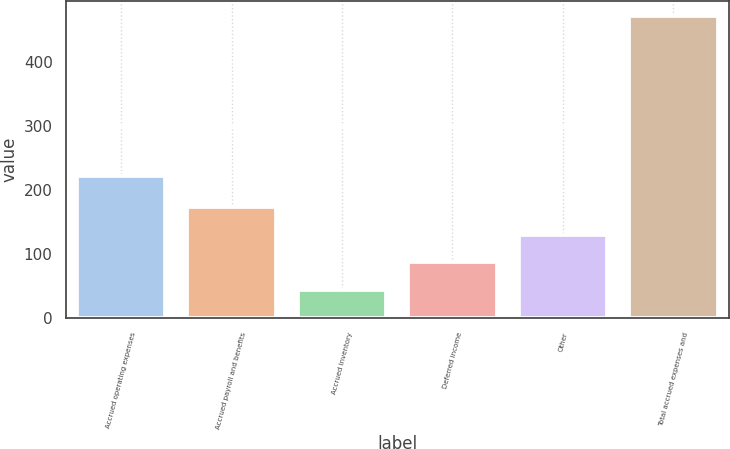Convert chart to OTSL. <chart><loc_0><loc_0><loc_500><loc_500><bar_chart><fcel>Accrued operating expenses<fcel>Accrued payroll and benefits<fcel>Accrued inventory<fcel>Deferred income<fcel>Other<fcel>Total accrued expenses and<nl><fcel>221.9<fcel>172.91<fcel>44.6<fcel>87.37<fcel>130.14<fcel>472.3<nl></chart> 